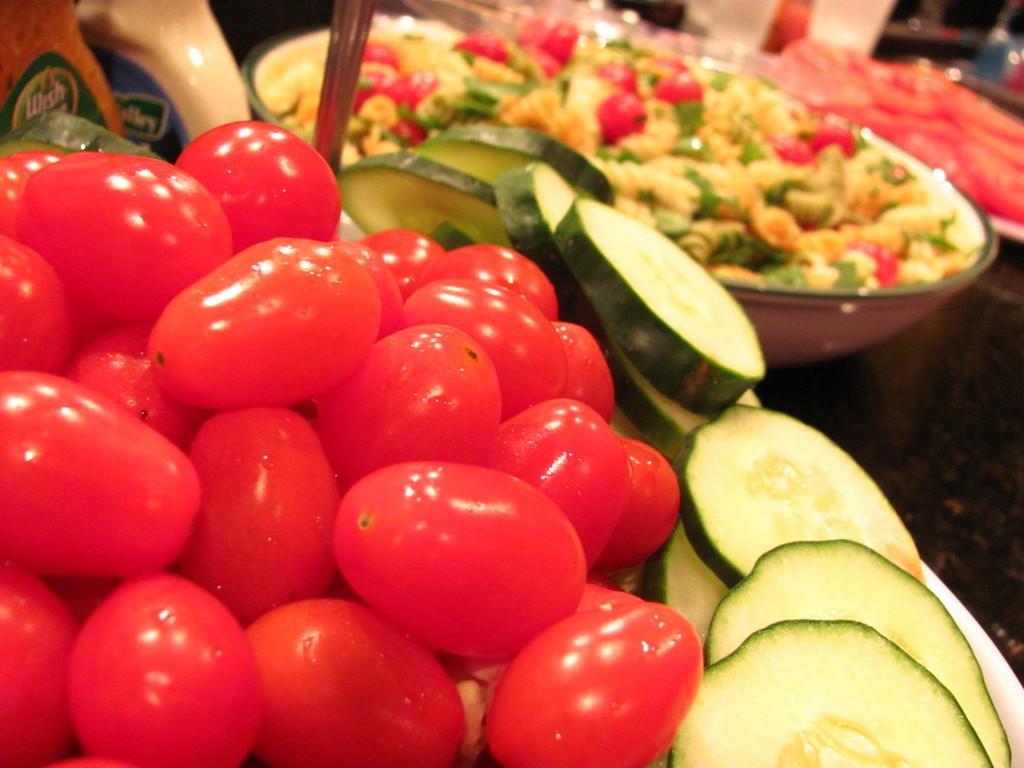Could you give a brief overview of what you see in this image? In the picture I can see vegetables and food items in objects. I can also see some other objects. 